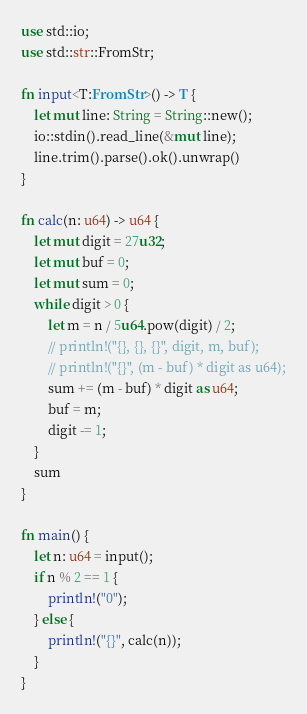<code> <loc_0><loc_0><loc_500><loc_500><_Rust_>use std::io;
use std::str::FromStr;

fn input<T:FromStr>() -> T {
    let mut line: String = String::new();
    io::stdin().read_line(&mut line);
    line.trim().parse().ok().unwrap()
}

fn calc(n: u64) -> u64 {
    let mut digit = 27u32;
    let mut buf = 0;
    let mut sum = 0;
    while digit > 0 {
        let m = n / 5u64.pow(digit) / 2;
        // println!("{}, {}, {}", digit, m, buf);
        // println!("{}", (m - buf) * digit as u64);
        sum += (m - buf) * digit as u64;
        buf = m;
        digit -= 1;
    }
    sum
}

fn main() {
    let n: u64 = input();
    if n % 2 == 1 {
        println!("0");
    } else {
        println!("{}", calc(n));
    }
}
</code> 